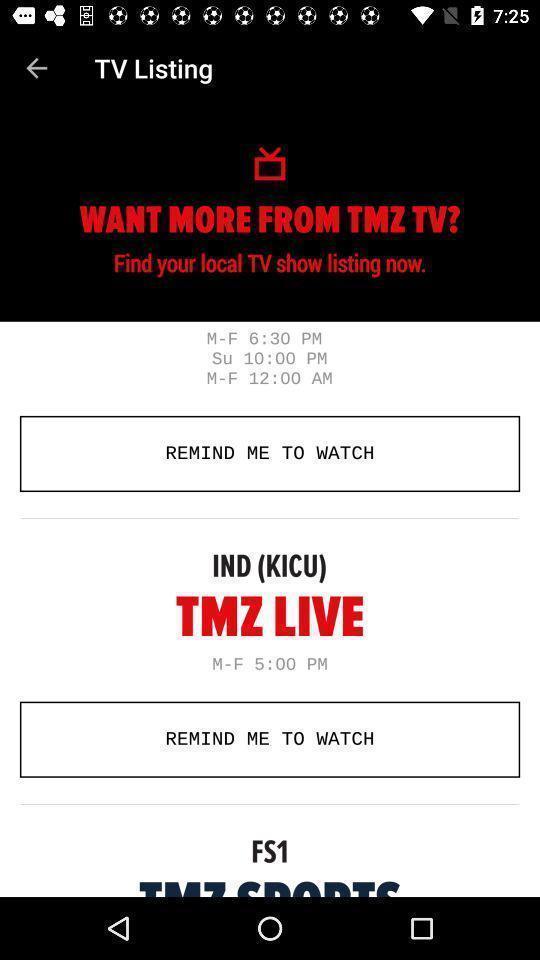Provide a description of this screenshot. Screen shows tv listings with times. 